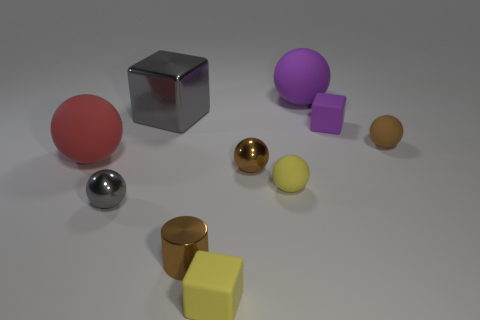The large red matte object has what shape?
Your response must be concise. Sphere. The other thing that is the same color as the large shiny thing is what size?
Your answer should be very brief. Small. What number of large cubes are right of the brown ball in front of the large red object?
Your answer should be compact. 0. How many other things are there of the same material as the tiny yellow ball?
Ensure brevity in your answer.  5. Are the ball behind the big metallic object and the gray thing that is behind the small gray metal sphere made of the same material?
Ensure brevity in your answer.  No. Are there any other things that have the same shape as the red thing?
Offer a very short reply. Yes. Do the cylinder and the tiny brown sphere on the right side of the tiny purple block have the same material?
Your answer should be very brief. No. There is a small block on the left side of the small rubber ball in front of the small brown matte thing that is in front of the large block; what is its color?
Offer a very short reply. Yellow. What is the shape of the brown matte object that is the same size as the purple cube?
Your answer should be very brief. Sphere. Is there any other thing that has the same size as the red matte object?
Offer a terse response. Yes. 